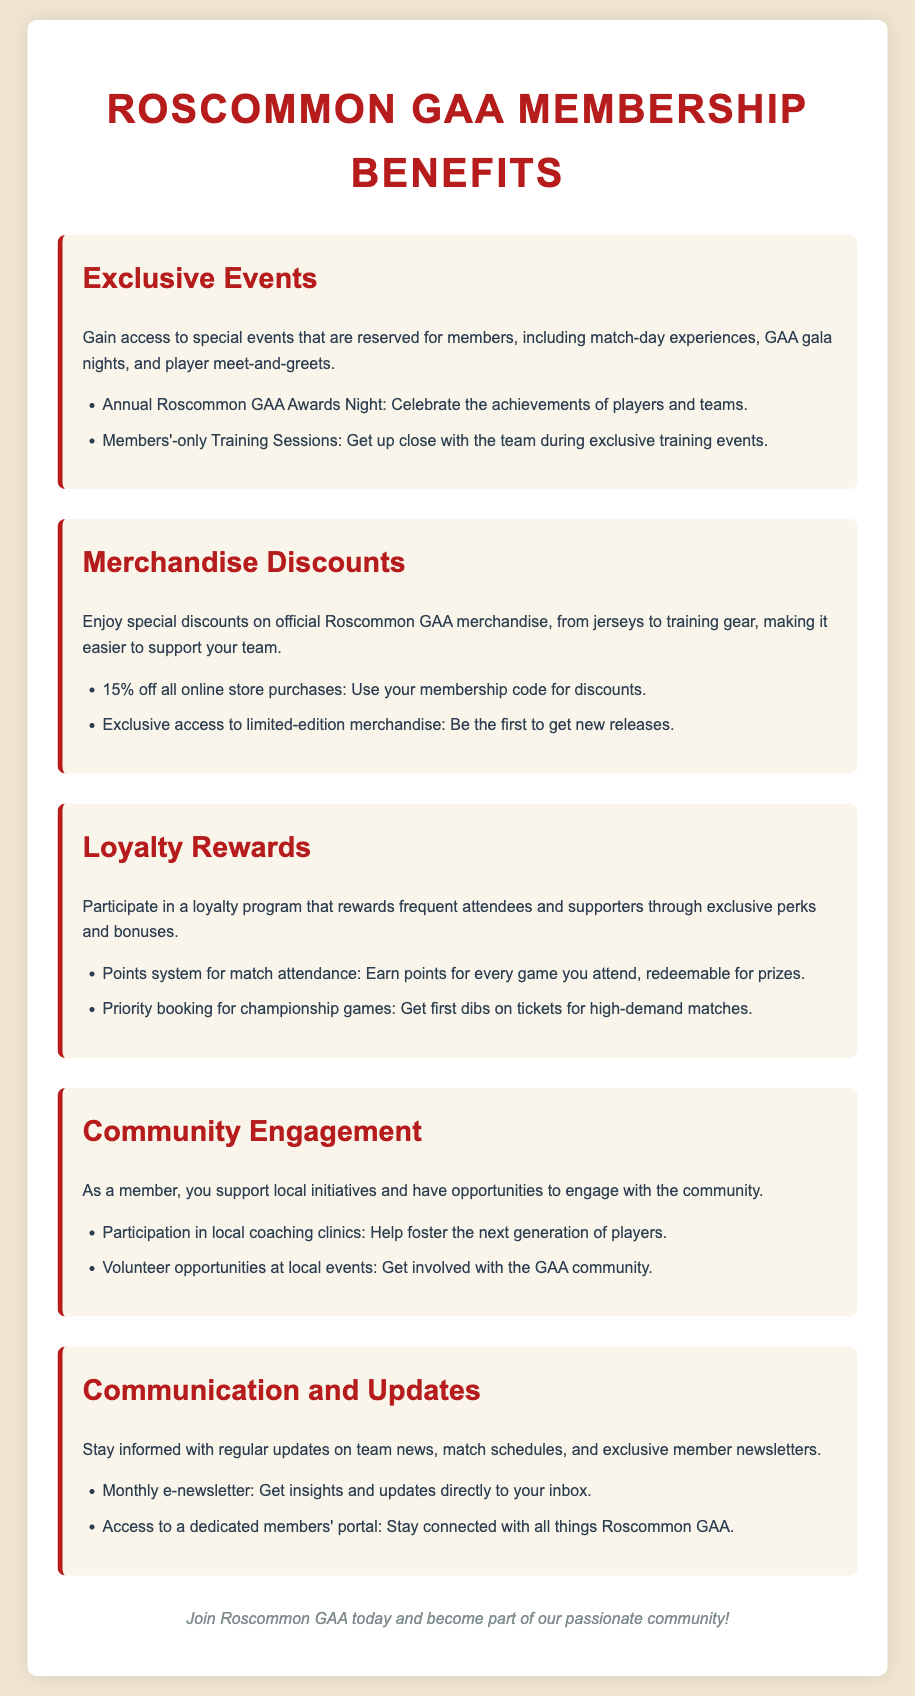What is the title of the document? The title of the document is highlighted in the header section as "Roscommon GAA Membership Benefits."
Answer: Roscommon GAA Membership Benefits How much discount do members receive on online store purchases? The document states that members receive a discount of 15% off all online store purchases.
Answer: 15% What type of events are reserved for members? The document lists "exclusive events" such as match-day experiences and GAA gala nights.
Answer: Exclusive events What is one of the rewards for participating in the loyalty program? The document mentions "points system for match attendance" as a reward in the loyalty program.
Answer: Points system for match attendance What is the purpose of community engagement for members? The document indicates that members support local initiatives and get involved in the community.
Answer: Support local initiatives Which section discusses communication and updates for members? The section titled "Communication and Updates" provides information on how members stay informed.
Answer: Communication and Updates What is one benefit of joining Roscommon GAA related to merchandise? Members have "exclusive access to limited-edition merchandise" as a benefit related to merchandise.
Answer: Exclusive access to limited-edition merchandise How often do members receive the e-newsletter? The document specifies that members receive a monthly e-newsletter.
Answer: Monthly What unique opportunity does membership provide concerning local coaching clinics? Membership allows for "participation in local coaching clinics."
Answer: Participation in local coaching clinics 